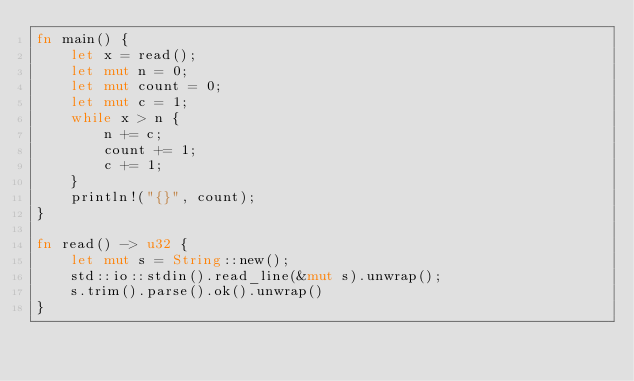Convert code to text. <code><loc_0><loc_0><loc_500><loc_500><_Rust_>fn main() {
    let x = read();
    let mut n = 0;
    let mut count = 0;
    let mut c = 1;
    while x > n {
        n += c;
        count += 1;
        c += 1;
    }
    println!("{}", count);
}

fn read() -> u32 {
    let mut s = String::new();
    std::io::stdin().read_line(&mut s).unwrap();
    s.trim().parse().ok().unwrap()
}
</code> 